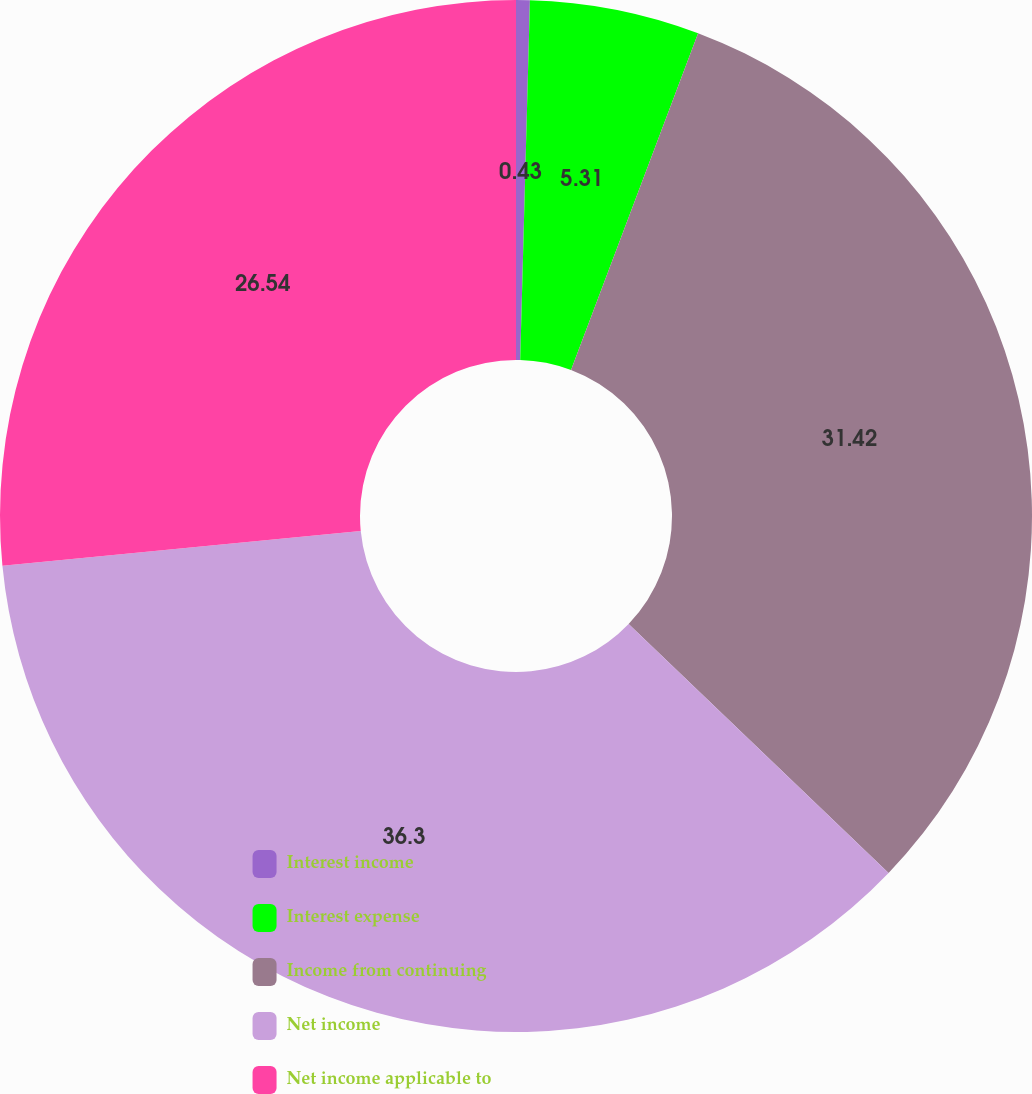Convert chart to OTSL. <chart><loc_0><loc_0><loc_500><loc_500><pie_chart><fcel>Interest income<fcel>Interest expense<fcel>Income from continuing<fcel>Net income<fcel>Net income applicable to<nl><fcel>0.43%<fcel>5.31%<fcel>31.42%<fcel>36.3%<fcel>26.54%<nl></chart> 